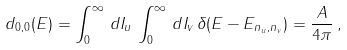Convert formula to latex. <formula><loc_0><loc_0><loc_500><loc_500>d _ { 0 , 0 } ( E ) = \int _ { 0 } ^ { \infty } \, d I _ { u } \, \int _ { 0 } ^ { \infty } \, d I _ { v } \, \delta ( E - E _ { n _ { u } , n _ { v } } ) = \frac { A } { 4 \pi } \, ,</formula> 